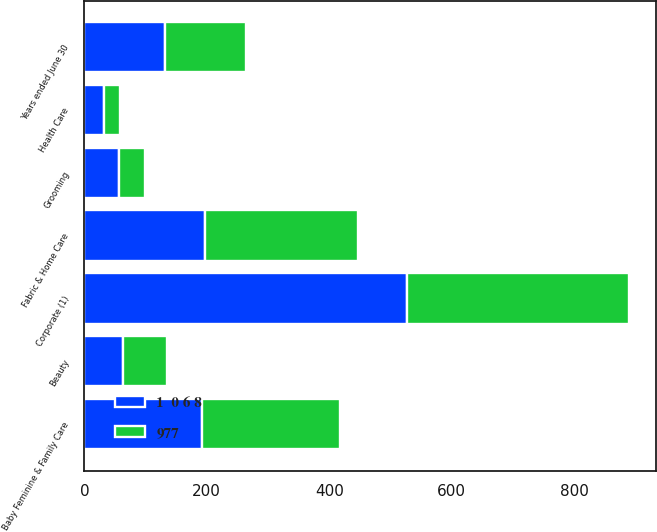Convert chart to OTSL. <chart><loc_0><loc_0><loc_500><loc_500><stacked_bar_chart><ecel><fcel>Years ended June 30<fcel>Beauty<fcel>Grooming<fcel>Health Care<fcel>Fabric & Home Care<fcel>Baby Feminine & Family Care<fcel>Corporate (1)<nl><fcel>977<fcel>132<fcel>72<fcel>42<fcel>26<fcel>250<fcel>225<fcel>362<nl><fcel>1  0 6 8<fcel>132<fcel>63<fcel>57<fcel>32<fcel>197<fcel>192<fcel>527<nl></chart> 